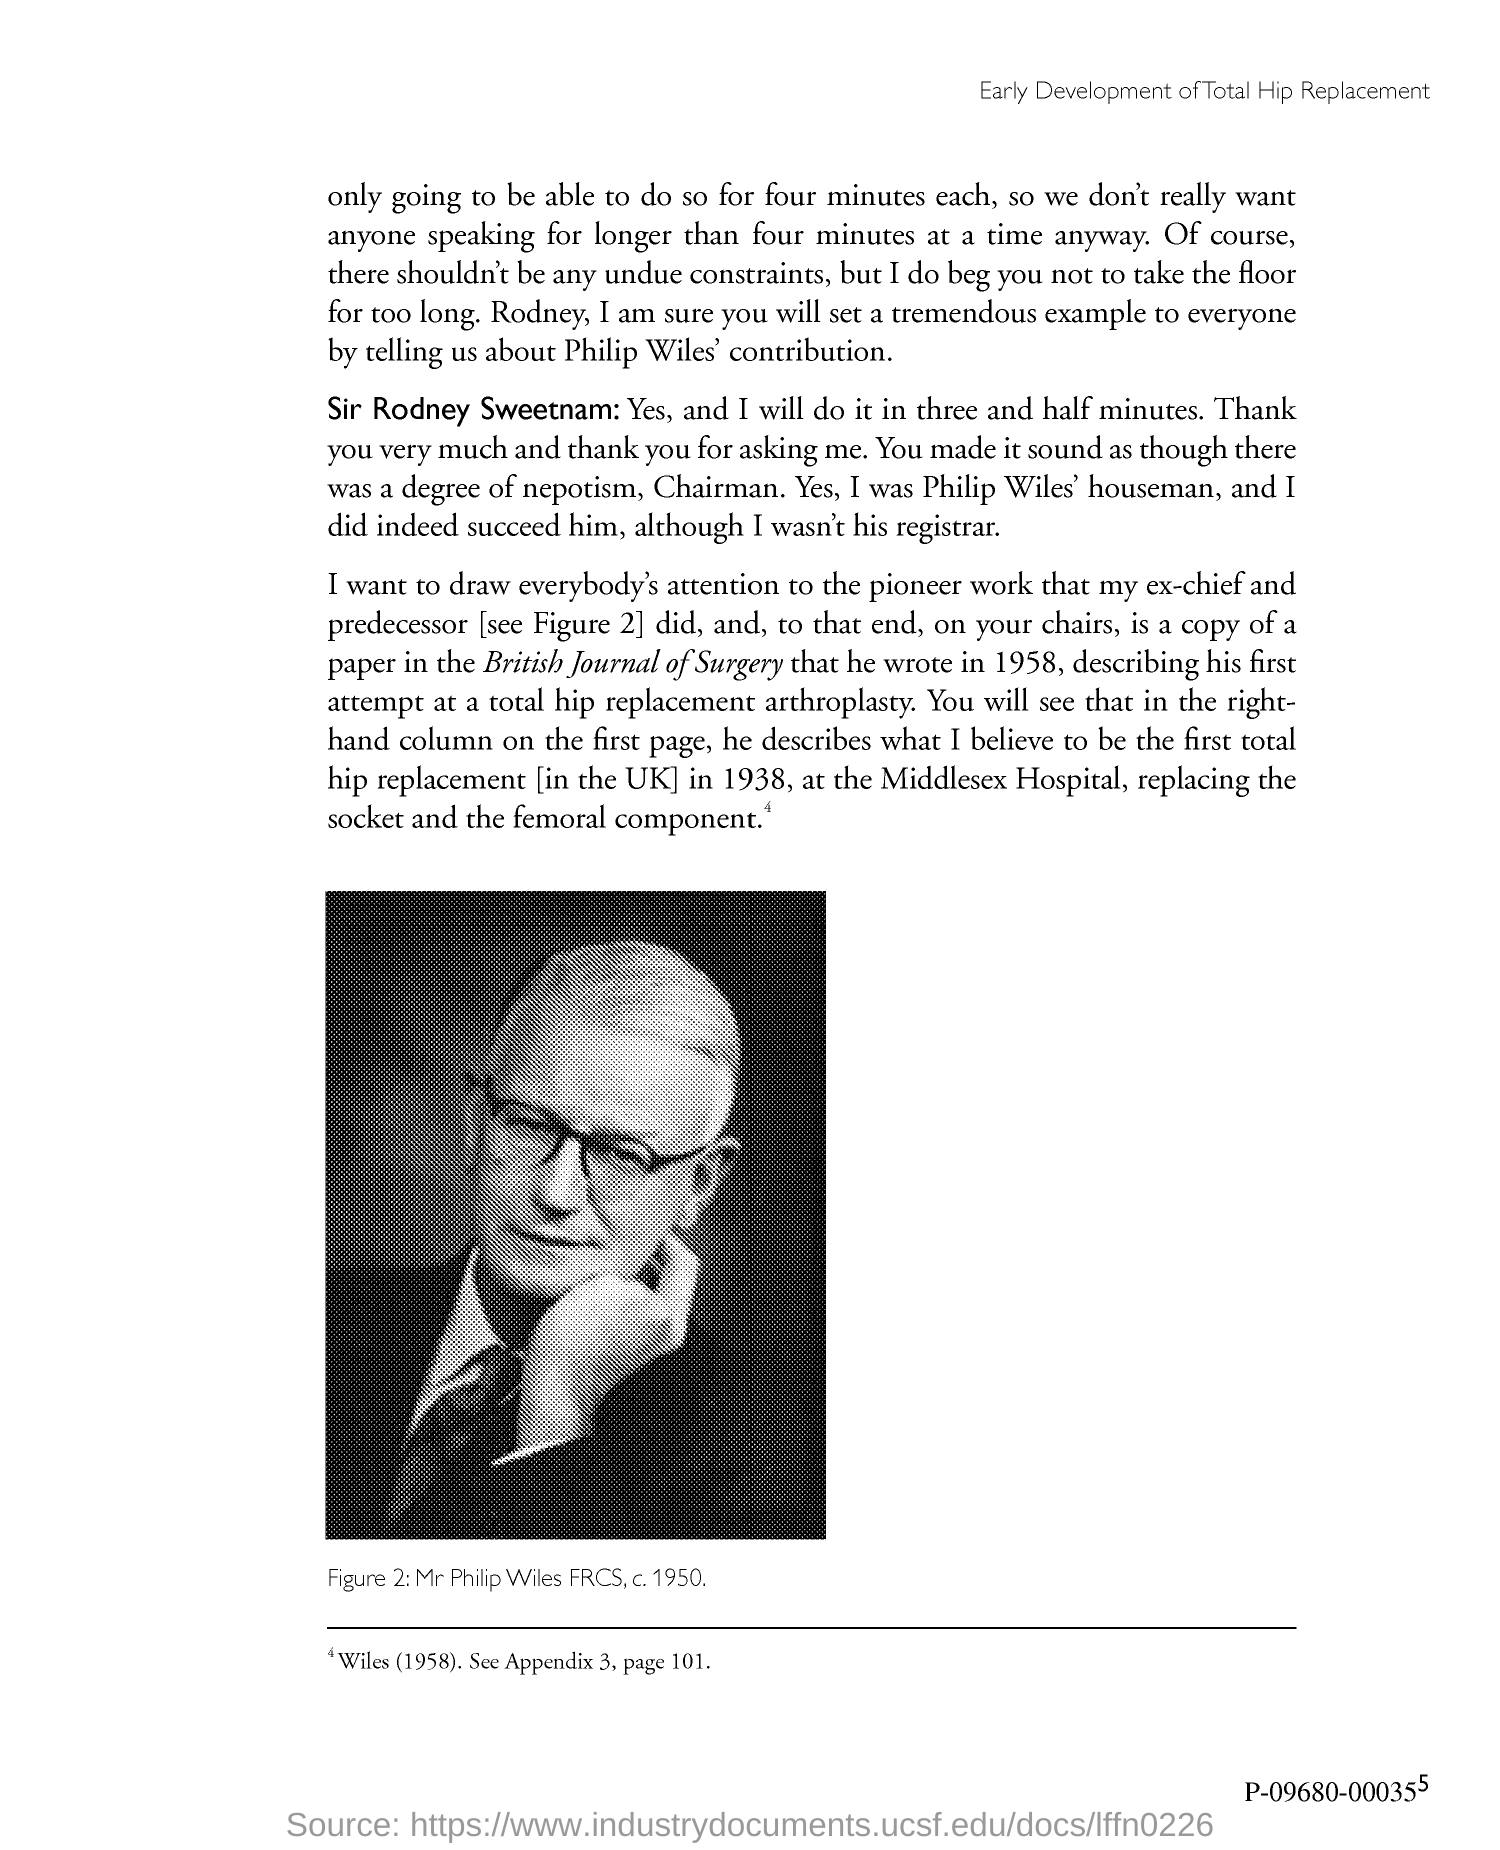Outline some significant characteristics in this image. The first hip replacement surgery of the individual was performed in 1938. 